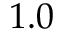Convert formula to latex. <formula><loc_0><loc_0><loc_500><loc_500>1 . 0</formula> 